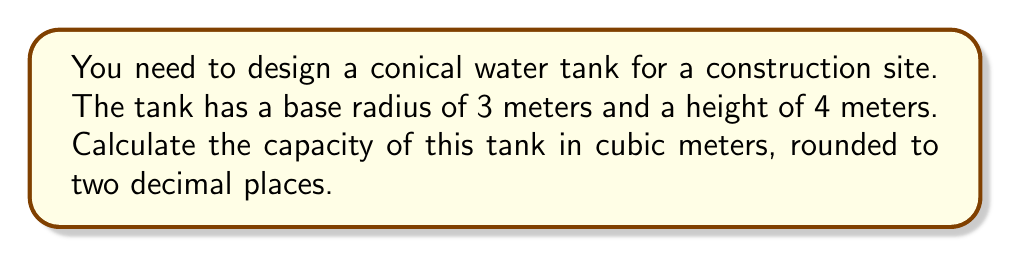Teach me how to tackle this problem. To calculate the capacity of a conical water tank, we need to use the formula for the volume of a cone:

$$V = \frac{1}{3}\pi r^2 h$$

Where:
$V$ = volume (capacity)
$r$ = radius of the base
$h$ = height of the cone

Given:
$r = 3$ meters
$h = 4$ meters

Let's substitute these values into the formula:

$$V = \frac{1}{3}\pi (3\text{ m})^2 (4\text{ m})$$

Simplify:
$$V = \frac{1}{3}\pi (9\text{ m}^2) (4\text{ m})$$
$$V = \frac{1}{3}\pi (36\text{ m}^3)$$
$$V = 12\pi\text{ m}^3$$

Now, let's calculate this value:
$$V \approx 12 \times 3.14159 \text{ m}^3$$
$$V \approx 37.69908 \text{ m}^3$$

Rounding to two decimal places:
$$V \approx 37.70 \text{ m}^3$$

[asy]
import geometry;

size(200);
pair A = (0,0), B = (3,0), C = (0,4);
draw(A--B--C--cycle);
draw(B--(3,4), dashed);
label("4 m", (0,2), W);
label("3 m", (1.5,0), S);
[/asy]
Answer: 37.70 m³ 